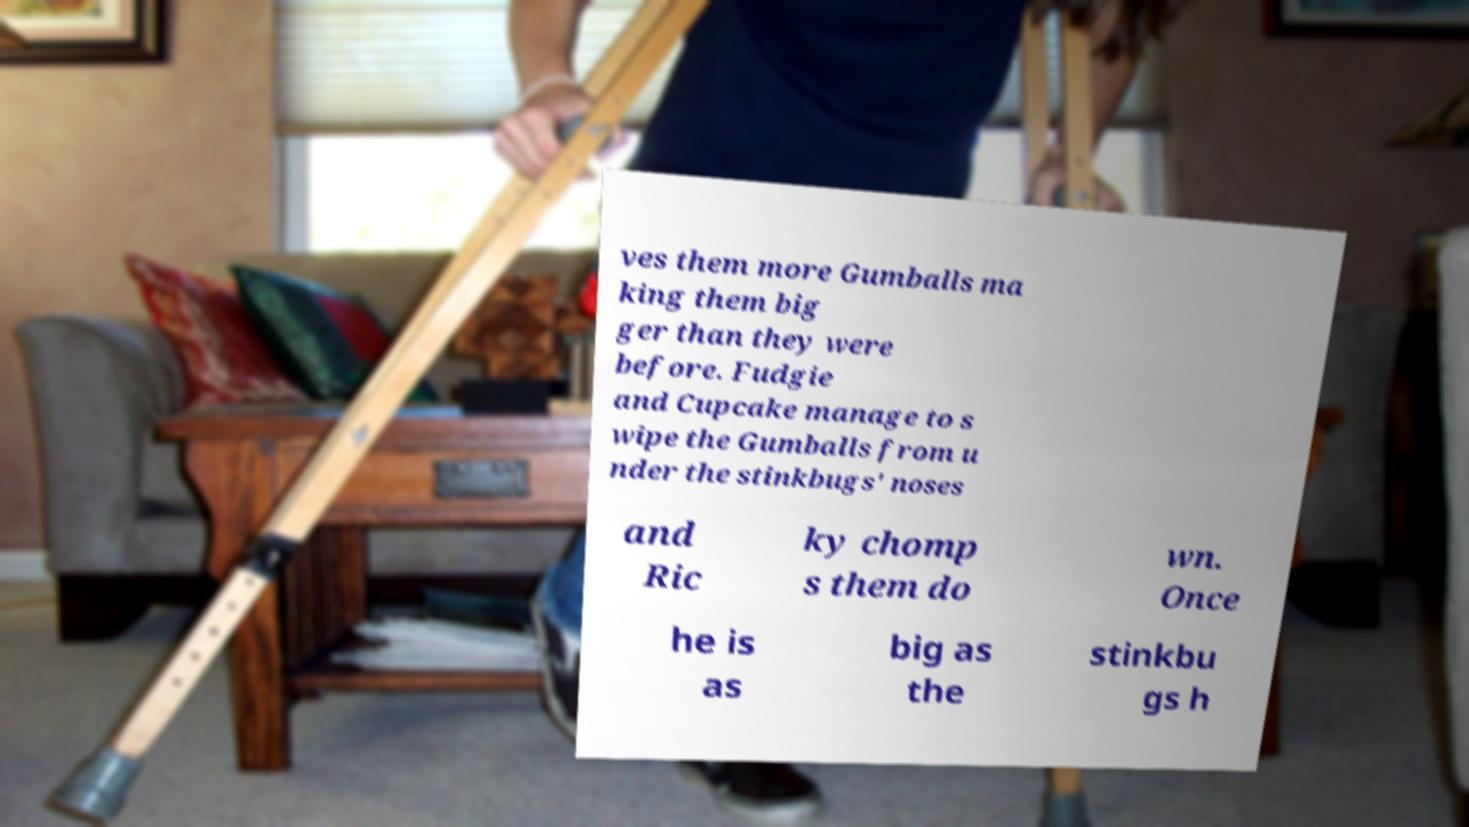I need the written content from this picture converted into text. Can you do that? ves them more Gumballs ma king them big ger than they were before. Fudgie and Cupcake manage to s wipe the Gumballs from u nder the stinkbugs' noses and Ric ky chomp s them do wn. Once he is as big as the stinkbu gs h 